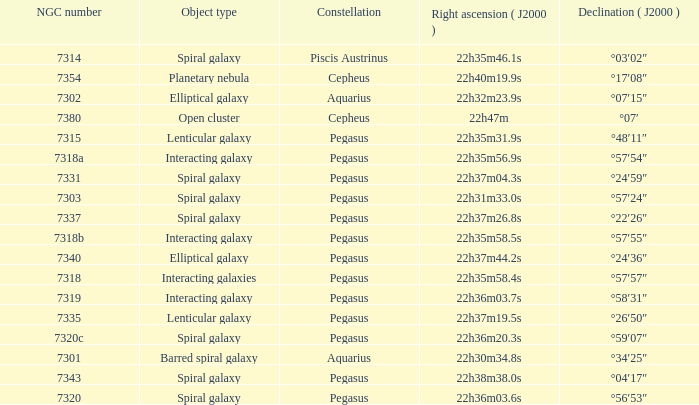What is the declination of the spiral galaxy Pegasus with 7337 NGC °22′26″. 